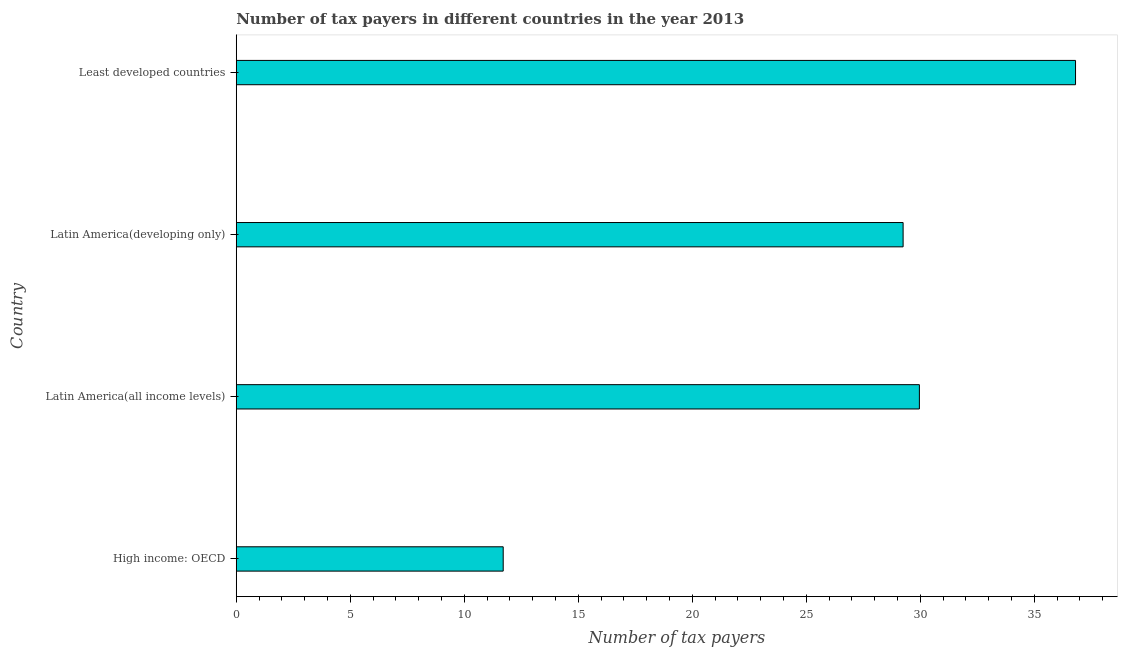Does the graph contain any zero values?
Keep it short and to the point. No. What is the title of the graph?
Your response must be concise. Number of tax payers in different countries in the year 2013. What is the label or title of the X-axis?
Keep it short and to the point. Number of tax payers. What is the number of tax payers in Least developed countries?
Make the answer very short. 36.8. Across all countries, what is the maximum number of tax payers?
Ensure brevity in your answer.  36.8. Across all countries, what is the minimum number of tax payers?
Provide a succinct answer. 11.71. In which country was the number of tax payers maximum?
Offer a terse response. Least developed countries. In which country was the number of tax payers minimum?
Give a very brief answer. High income: OECD. What is the sum of the number of tax payers?
Your response must be concise. 107.71. What is the difference between the number of tax payers in High income: OECD and Least developed countries?
Make the answer very short. -25.1. What is the average number of tax payers per country?
Offer a terse response. 26.93. What is the median number of tax payers?
Your answer should be compact. 29.6. What is the ratio of the number of tax payers in Latin America(developing only) to that in Least developed countries?
Ensure brevity in your answer.  0.8. Is the number of tax payers in High income: OECD less than that in Least developed countries?
Your response must be concise. Yes. Is the difference between the number of tax payers in High income: OECD and Least developed countries greater than the difference between any two countries?
Offer a terse response. Yes. What is the difference between the highest and the second highest number of tax payers?
Ensure brevity in your answer.  6.85. What is the difference between the highest and the lowest number of tax payers?
Give a very brief answer. 25.1. In how many countries, is the number of tax payers greater than the average number of tax payers taken over all countries?
Make the answer very short. 3. Are all the bars in the graph horizontal?
Provide a succinct answer. Yes. How many countries are there in the graph?
Provide a succinct answer. 4. What is the difference between two consecutive major ticks on the X-axis?
Keep it short and to the point. 5. Are the values on the major ticks of X-axis written in scientific E-notation?
Your response must be concise. No. What is the Number of tax payers of High income: OECD?
Give a very brief answer. 11.71. What is the Number of tax payers in Latin America(all income levels)?
Your answer should be compact. 29.96. What is the Number of tax payers in Latin America(developing only)?
Provide a succinct answer. 29.24. What is the Number of tax payers in Least developed countries?
Keep it short and to the point. 36.8. What is the difference between the Number of tax payers in High income: OECD and Latin America(all income levels)?
Offer a terse response. -18.25. What is the difference between the Number of tax payers in High income: OECD and Latin America(developing only)?
Provide a succinct answer. -17.54. What is the difference between the Number of tax payers in High income: OECD and Least developed countries?
Keep it short and to the point. -25.1. What is the difference between the Number of tax payers in Latin America(all income levels) and Latin America(developing only)?
Offer a very short reply. 0.71. What is the difference between the Number of tax payers in Latin America(all income levels) and Least developed countries?
Your response must be concise. -6.85. What is the difference between the Number of tax payers in Latin America(developing only) and Least developed countries?
Give a very brief answer. -7.56. What is the ratio of the Number of tax payers in High income: OECD to that in Latin America(all income levels)?
Keep it short and to the point. 0.39. What is the ratio of the Number of tax payers in High income: OECD to that in Latin America(developing only)?
Give a very brief answer. 0.4. What is the ratio of the Number of tax payers in High income: OECD to that in Least developed countries?
Offer a very short reply. 0.32. What is the ratio of the Number of tax payers in Latin America(all income levels) to that in Least developed countries?
Ensure brevity in your answer.  0.81. What is the ratio of the Number of tax payers in Latin America(developing only) to that in Least developed countries?
Your response must be concise. 0.8. 